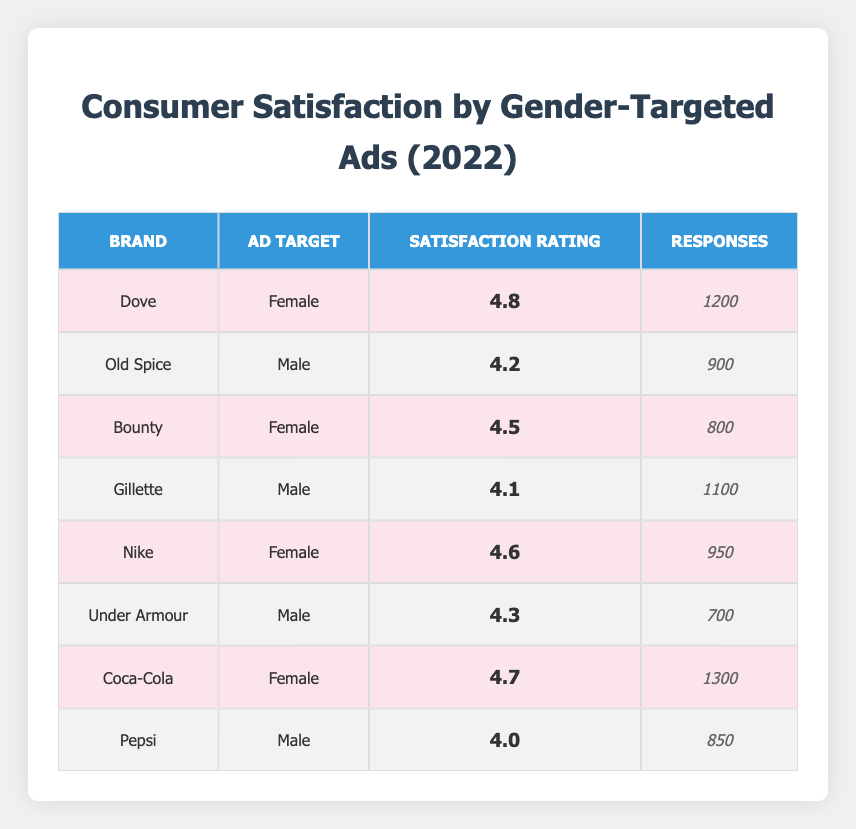What is the satisfaction rating for Dove? The rating for Dove is listed directly in the table, under 'Satisfaction Rating' for the brand Dove, which is 4.8.
Answer: 4.8 What brand received the lowest satisfaction rating among male-targeted ads? The table shows that Old Spice has a satisfaction rating of 4.2, Gillette has 4.1, and Under Armour has 4.3. Among these, Gillette has the lowest rating of 4.1.
Answer: Gillette What is the total number of responses for all female-targeted ads? The responses for female-targeted ads are Dove (1200), Bounty (800), Nike (950), and Coca-Cola (1300). Summing these gives 1200 + 800 + 950 + 1300 = 4250.
Answer: 4250 Is the satisfaction rating for Pepsi greater than 4.0? According to the table, Pepsi has a satisfaction rating of 4.0, which means it is not greater than 4.0.
Answer: No What is the average satisfaction rating for male-targeted ads? The satisfaction ratings for male-targeted ads are Old Spice (4.2), Gillette (4.1), and Under Armour (4.3). To find the average, sum these ratings: 4.2 + 4.1 + 4.3 = 12.6. Divide by the number of ratings (3), giving 12.6 / 3 = 4.2.
Answer: 4.2 Which brand has the highest satisfaction rating and what is it? The satisfaction ratings for all brands are compared. Dove (4.8), Coca-Cola (4.7), Nike (4.6), and all male-targeted brands are lower than these values. Therefore, Dove has the highest rating at 4.8.
Answer: Dove, 4.8 Does Coca-Cola have more responses than Nike? The table shows Coca-Cola has 1300 responses while Nike has 950 responses. Since 1300 is greater than 950, Coca-Cola has more responses.
Answer: Yes What is the difference in satisfaction ratings between the highest-rated female target brand and the lowest-rated male target brand? Dove has the highest female-targeted rating at 4.8 and Gillette has the lowest male-targeted rating at 4.1. The difference is 4.8 - 4.1 = 0.7.
Answer: 0.7 What is the total satisfaction rating for all brands in the table? We sum the satisfaction ratings: 4.8 (Dove) + 4.2 (Old Spice) + 4.5 (Bounty) + 4.1 (Gillette) + 4.6 (Nike) + 4.3 (Under Armour) + 4.7 (Coca-Cola) + 4.0 (Pepsi) = 34.2.
Answer: 34.2 